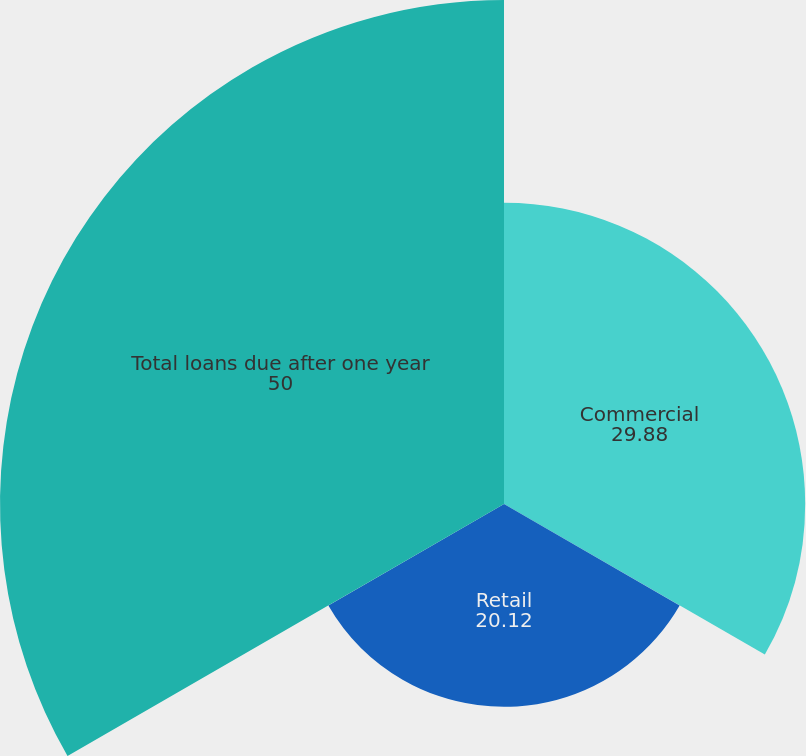Convert chart to OTSL. <chart><loc_0><loc_0><loc_500><loc_500><pie_chart><fcel>Commercial<fcel>Retail<fcel>Total loans due after one year<nl><fcel>29.88%<fcel>20.12%<fcel>50.0%<nl></chart> 